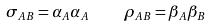<formula> <loc_0><loc_0><loc_500><loc_500>\sigma _ { A B } = \alpha _ { A } \alpha _ { A } \quad \rho _ { A B } = \beta _ { A } \beta _ { B }</formula> 